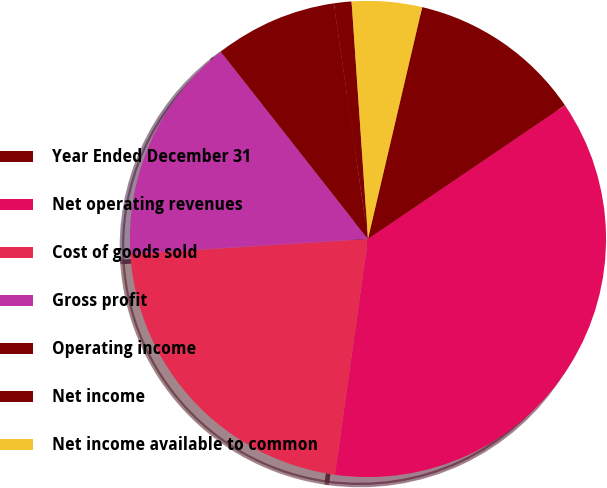Convert chart. <chart><loc_0><loc_0><loc_500><loc_500><pie_chart><fcel>Year Ended December 31<fcel>Net operating revenues<fcel>Cost of goods sold<fcel>Gross profit<fcel>Operating income<fcel>Net income<fcel>Net income available to common<nl><fcel>11.85%<fcel>36.7%<fcel>21.77%<fcel>15.4%<fcel>8.3%<fcel>1.2%<fcel>4.75%<nl></chart> 